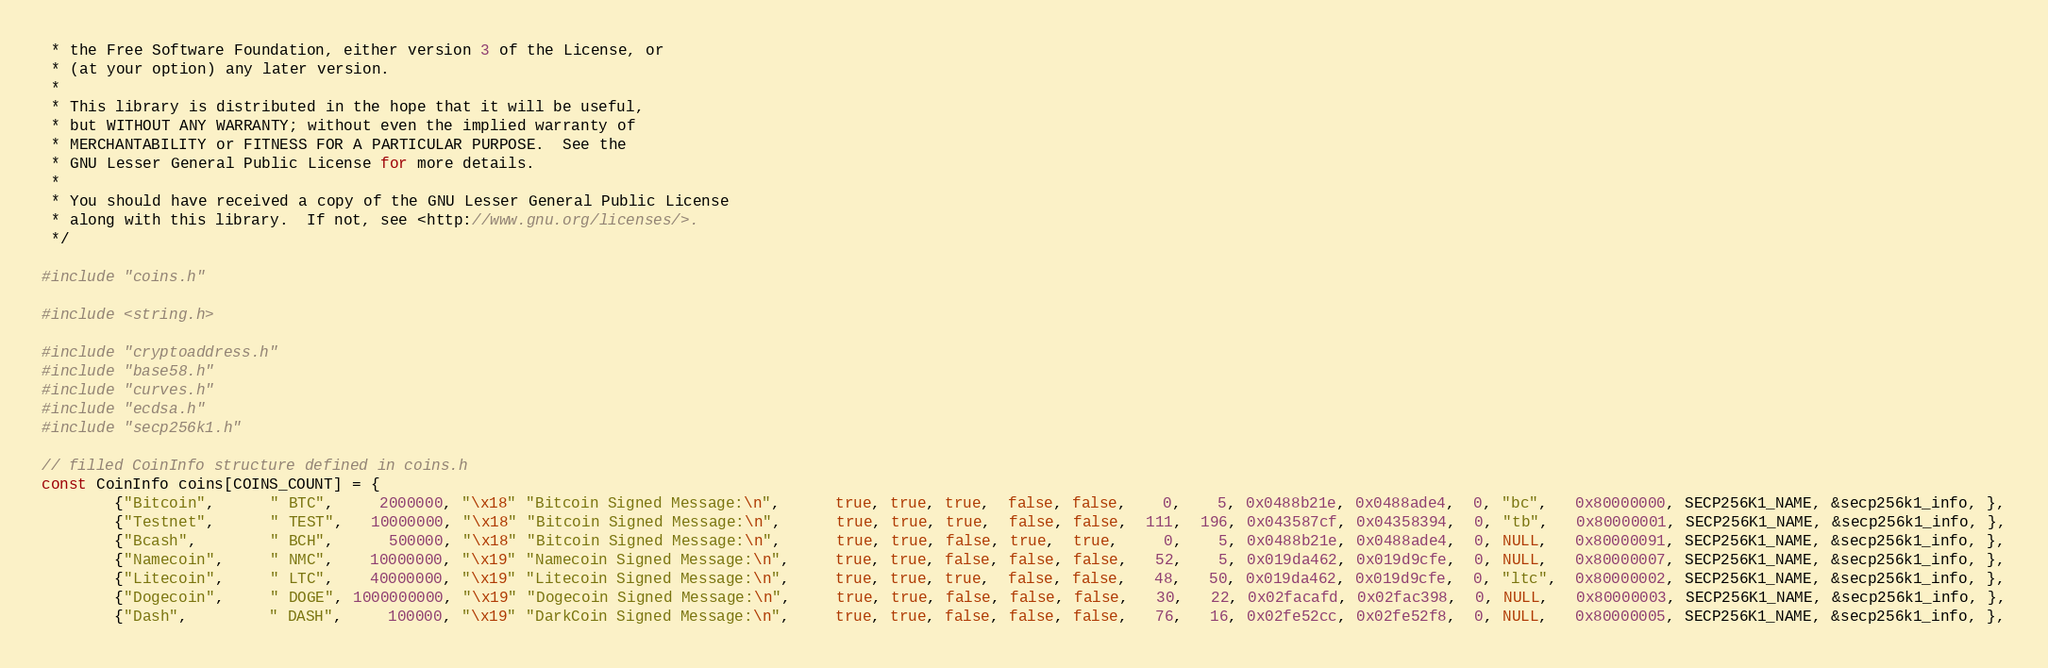<code> <loc_0><loc_0><loc_500><loc_500><_C_> * the Free Software Foundation, either version 3 of the License, or
 * (at your option) any later version.
 *
 * This library is distributed in the hope that it will be useful,
 * but WITHOUT ANY WARRANTY; without even the implied warranty of
 * MERCHANTABILITY or FITNESS FOR A PARTICULAR PURPOSE.  See the
 * GNU Lesser General Public License for more details.
 *
 * You should have received a copy of the GNU Lesser General Public License
 * along with this library.  If not, see <http://www.gnu.org/licenses/>.
 */

#include "coins.h"

#include <string.h>

#include "cryptoaddress.h"
#include "base58.h"
#include "curves.h"
#include "ecdsa.h"
#include "secp256k1.h"

// filled CoinInfo structure defined in coins.h
const CoinInfo coins[COINS_COUNT] = {
		{"Bitcoin",      " BTC",     2000000, "\x18" "Bitcoin Signed Message:\n",      true, true, true,  false, false,    0,    5, 0x0488b21e, 0x0488ade4,  0, "bc",   0x80000000, SECP256K1_NAME, &secp256k1_info, },
		{"Testnet",      " TEST",   10000000, "\x18" "Bitcoin Signed Message:\n",      true, true, true,  false, false,  111,  196, 0x043587cf, 0x04358394,  0, "tb",   0x80000001, SECP256K1_NAME, &secp256k1_info, },
		{"Bcash",        " BCH",      500000, "\x18" "Bitcoin Signed Message:\n",      true, true, false, true,  true,     0,    5, 0x0488b21e, 0x0488ade4,  0, NULL,   0x80000091, SECP256K1_NAME, &secp256k1_info, },
		{"Namecoin",     " NMC",    10000000, "\x19" "Namecoin Signed Message:\n",     true, true, false, false, false,   52,    5, 0x019da462, 0x019d9cfe,  0, NULL,   0x80000007, SECP256K1_NAME, &secp256k1_info, },
		{"Litecoin",     " LTC",    40000000, "\x19" "Litecoin Signed Message:\n",     true, true, true,  false, false,   48,   50, 0x019da462, 0x019d9cfe,  0, "ltc",  0x80000002, SECP256K1_NAME, &secp256k1_info, },
		{"Dogecoin",     " DOGE", 1000000000, "\x19" "Dogecoin Signed Message:\n",     true, true, false, false, false,   30,   22, 0x02facafd, 0x02fac398,  0, NULL,   0x80000003, SECP256K1_NAME, &secp256k1_info, },
		{"Dash",         " DASH",     100000, "\x19" "DarkCoin Signed Message:\n",     true, true, false, false, false,   76,   16, 0x02fe52cc, 0x02fe52f8,  0, NULL,   0x80000005, SECP256K1_NAME, &secp256k1_info, },</code> 